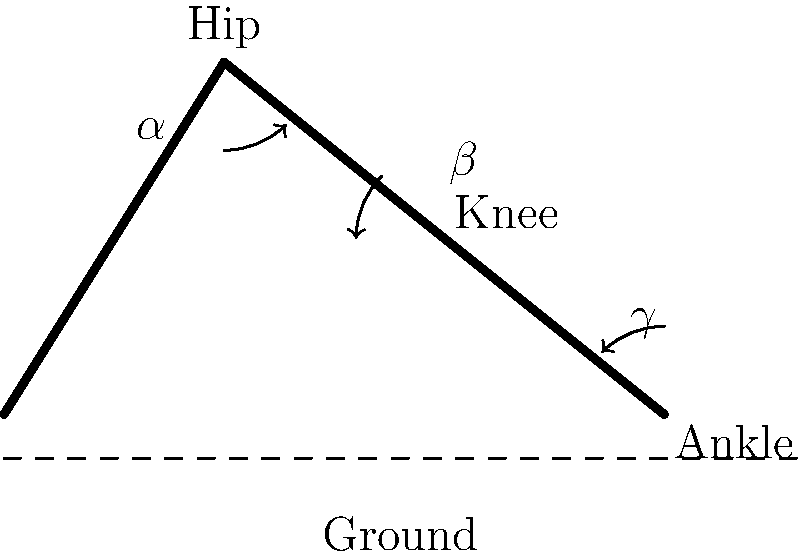In the diagram of a dog's hind leg during the walking stance phase, angles $\alpha$, $\beta$, and $\gamma$ represent the hip, knee, and ankle joint angles, respectively. If the typical ranges of motion for these joints during walking are:

Hip (α): 20° to 60°
Knee (β): 30° to 70°
Ankle (γ): 35° to 75°

What is the total range of motion (in degrees) for all three joints combined during a complete walking cycle? To find the total range of motion for all three joints, we need to:

1. Calculate the range of motion for each joint:
   Hip (α): 60° - 20° = 40°
   Knee (β): 70° - 30° = 40°
   Ankle (γ): 75° - 35° = 40°

2. Sum the ranges of motion for all three joints:
   Total range = Hip range + Knee range + Ankle range
   Total range = 40° + 40° + 40° = 120°

Therefore, the total range of motion for all three joints combined during a complete walking cycle is 120°.
Answer: 120° 